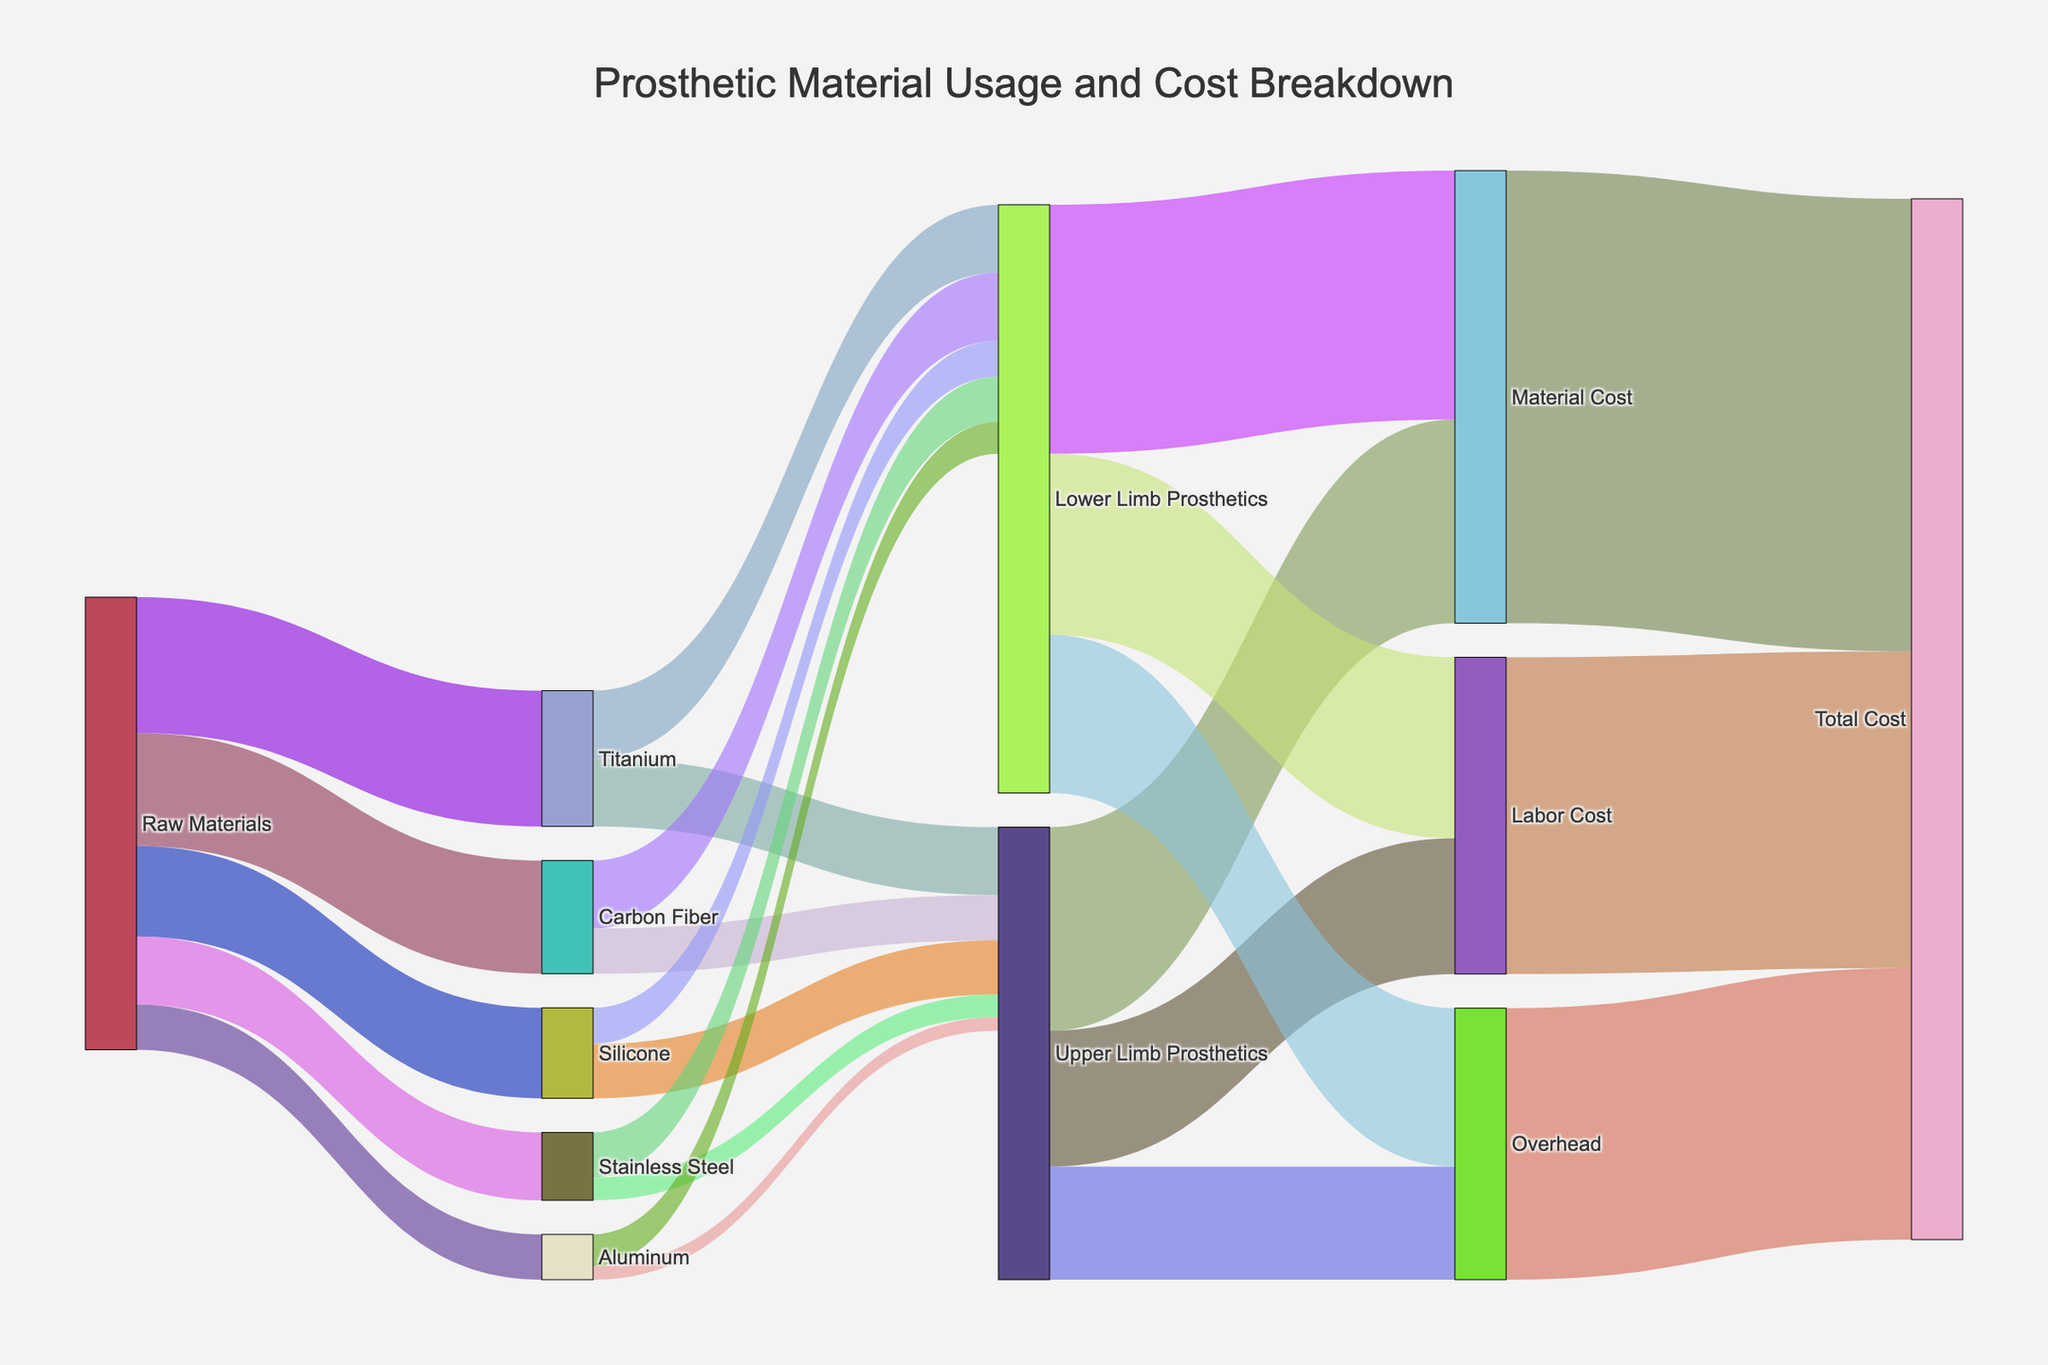How many distinct raw materials are used in prosthetic creation? By looking at the sources connected to "Raw Materials", we can count the distinct raw materials listed. These are Titanium, Carbon Fiber, Silicone, Stainless Steel, and Aluminum, making a total of 5 distinct raw materials.
Answer: 5 What is the total cost breakdown for Upper Limb Prosthetics? For Upper Limb Prosthetics, we need to sum up the Material Cost, Labor Cost, and Overhead. According to the figure, these values are 45, 30, and 25 respectively. Therefore, the total cost is 45 + 30 + 25 = 100.
Answer: 100 Which material has the highest usage for Lower Limb Prosthetics? By tracing the links from the raw materials to Lower Limb Prosthetics, we can compare the usage values. Titanium is used 15 units,  Carbon Fiber 15 units, Silicone 8 units, Stainless Steel 10 units, and Aluminum 7 units. Titanium and Carbon Fiber both have the highest usage with 15 units each.
Answer: Titanium and Carbon Fiber What is the total value flowing from Raw Materials to all prosthetics combined? To find this, sum up all the values flowing out from "Raw Materials". The values are 30 (Titanium) + 25 (Carbon Fiber) + 20 (Silicone) + 15 (Stainless Steel) + 10 (Aluminum). The total value is 100.
Answer: 100 How much does Titanium contribute to the Material Cost? Titanium contributes to both Upper and Lower Limb Prosthetics. The values are 15 units each for both. Total contribution to Material Cost is 15 + 15 = 30.
Answer: 30 What's the total flow of cost types that leads into Total Cost? The Total Cost node is connected to Material Cost, Labor Cost, and Overhead. Summing these values gives us 100 (Material Cost) + 70 (Labor Cost) + 60 (Overhead) = 230.
Answer: 230 Which limb prosthetics type has the higher Labor Cost? By comparing the Labor Cost values connected to Upper Limb Prosthetics and Lower Limb Prosthetics, we can see the values are 30 and 40 respectively. Lower Limb Prosthetics has a higher Labor Cost.
Answer: Lower Limb Prosthetics Compare the Material Cost between Upper and Lower Limb Prosthetics. To compare, look at the values next to Material Cost nodes connected to both prosthetic types. Upper Limb Prosthetics is 45 and Lower Limb Prosthetics is 55. Thus, Lower Limb Prosthetics has a higher Material Cost.
Answer: Lower Limb Prosthetics What is the color pattern used to differentiate the connections in the diagram? The links connecting nodes have colors assigned in different shades with some transparency. Each link has a distinct color to differentiate the connection paths. Colors may include different shades of red, green, blue, etc.
Answer: Different shades with transparency How much value does Aluminum contribute to the Lower Limb Prosthetics? Trace the value flow from Aluminum to Lower Limb Prosthetics. The chart shows this value as 7 units.
Answer: 7 